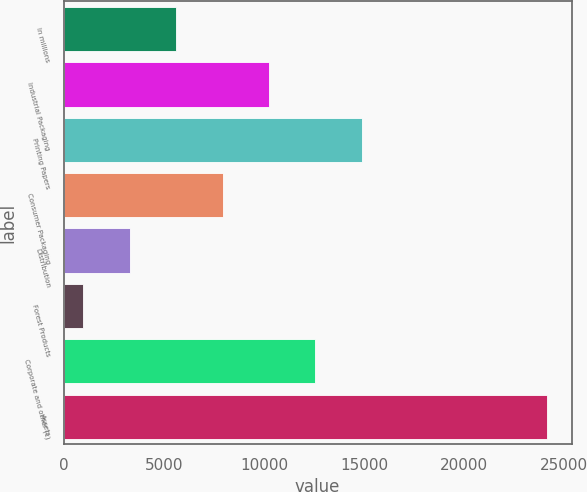Convert chart to OTSL. <chart><loc_0><loc_0><loc_500><loc_500><bar_chart><fcel>In millions<fcel>Industrial Packaging<fcel>Printing Papers<fcel>Consumer Packaging<fcel>Distribution<fcel>Forest Products<fcel>Corporate and other (c)<fcel>Assets<nl><fcel>5619<fcel>10254<fcel>14889<fcel>7936.5<fcel>3301.5<fcel>984<fcel>12571.5<fcel>24159<nl></chart> 